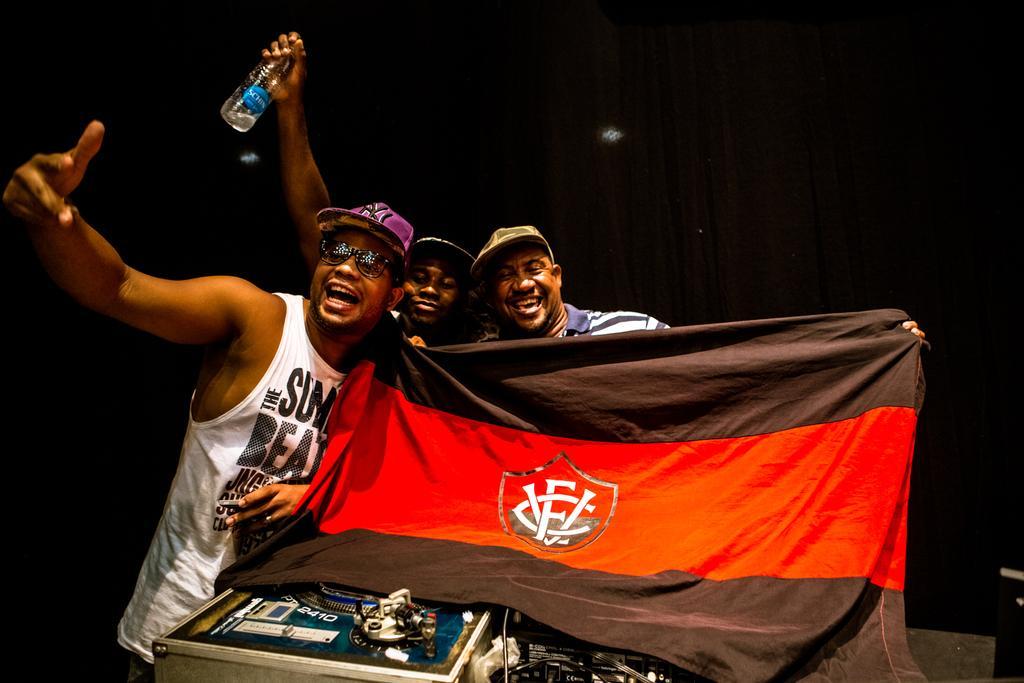Describe this image in one or two sentences. In the center of the image we can see three persons are standing and they are holding one flag. And the center person is holding water bottle. And we can see they are smiling, which we can see on their faces. And they are wearing caps. In front of them, there is a table. On the table, we can see one toy, tools and a few other objects. In the background we can see the lights. 